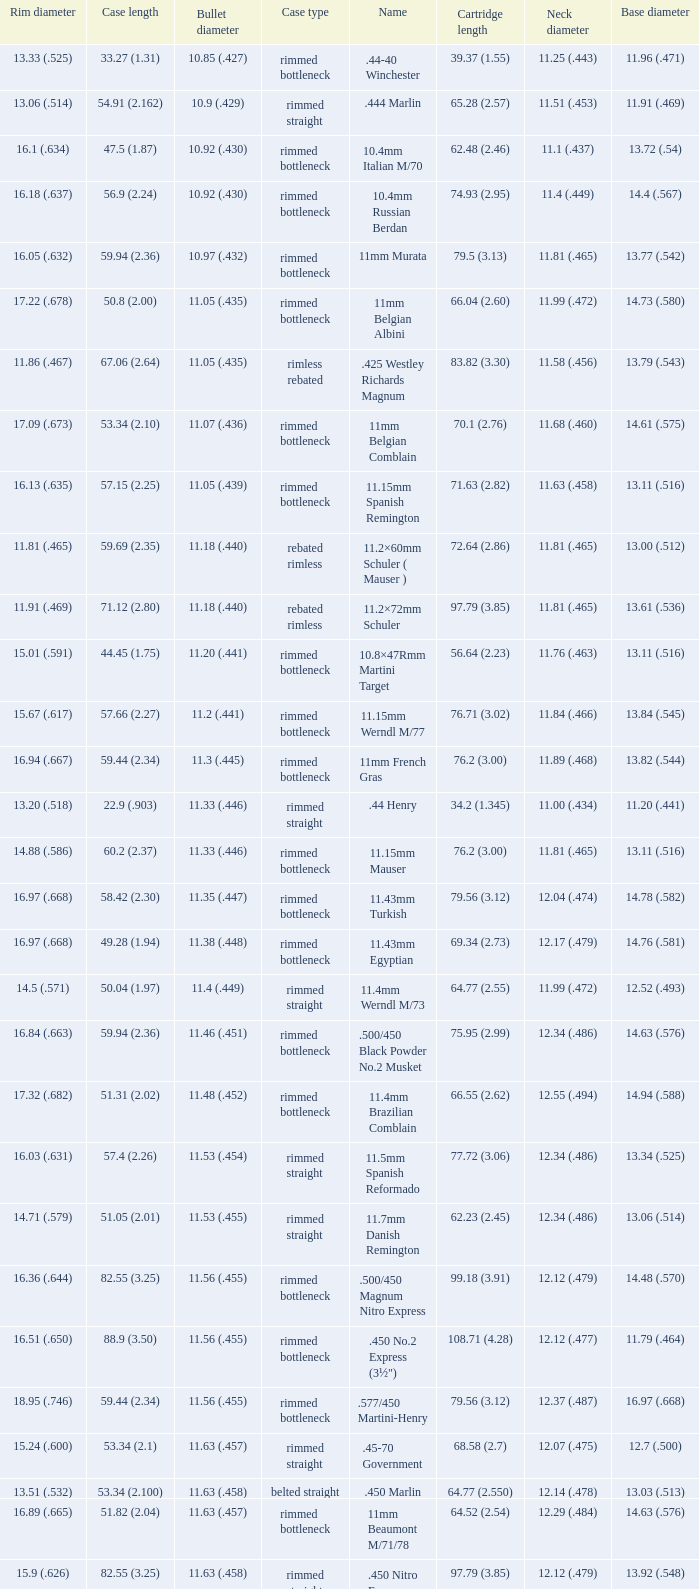Which Case length has a Rim diameter of 13.20 (.518)? 22.9 (.903). 